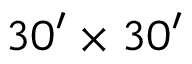<formula> <loc_0><loc_0><loc_500><loc_500>3 0 ^ { \prime } \times 3 0 ^ { \prime }</formula> 